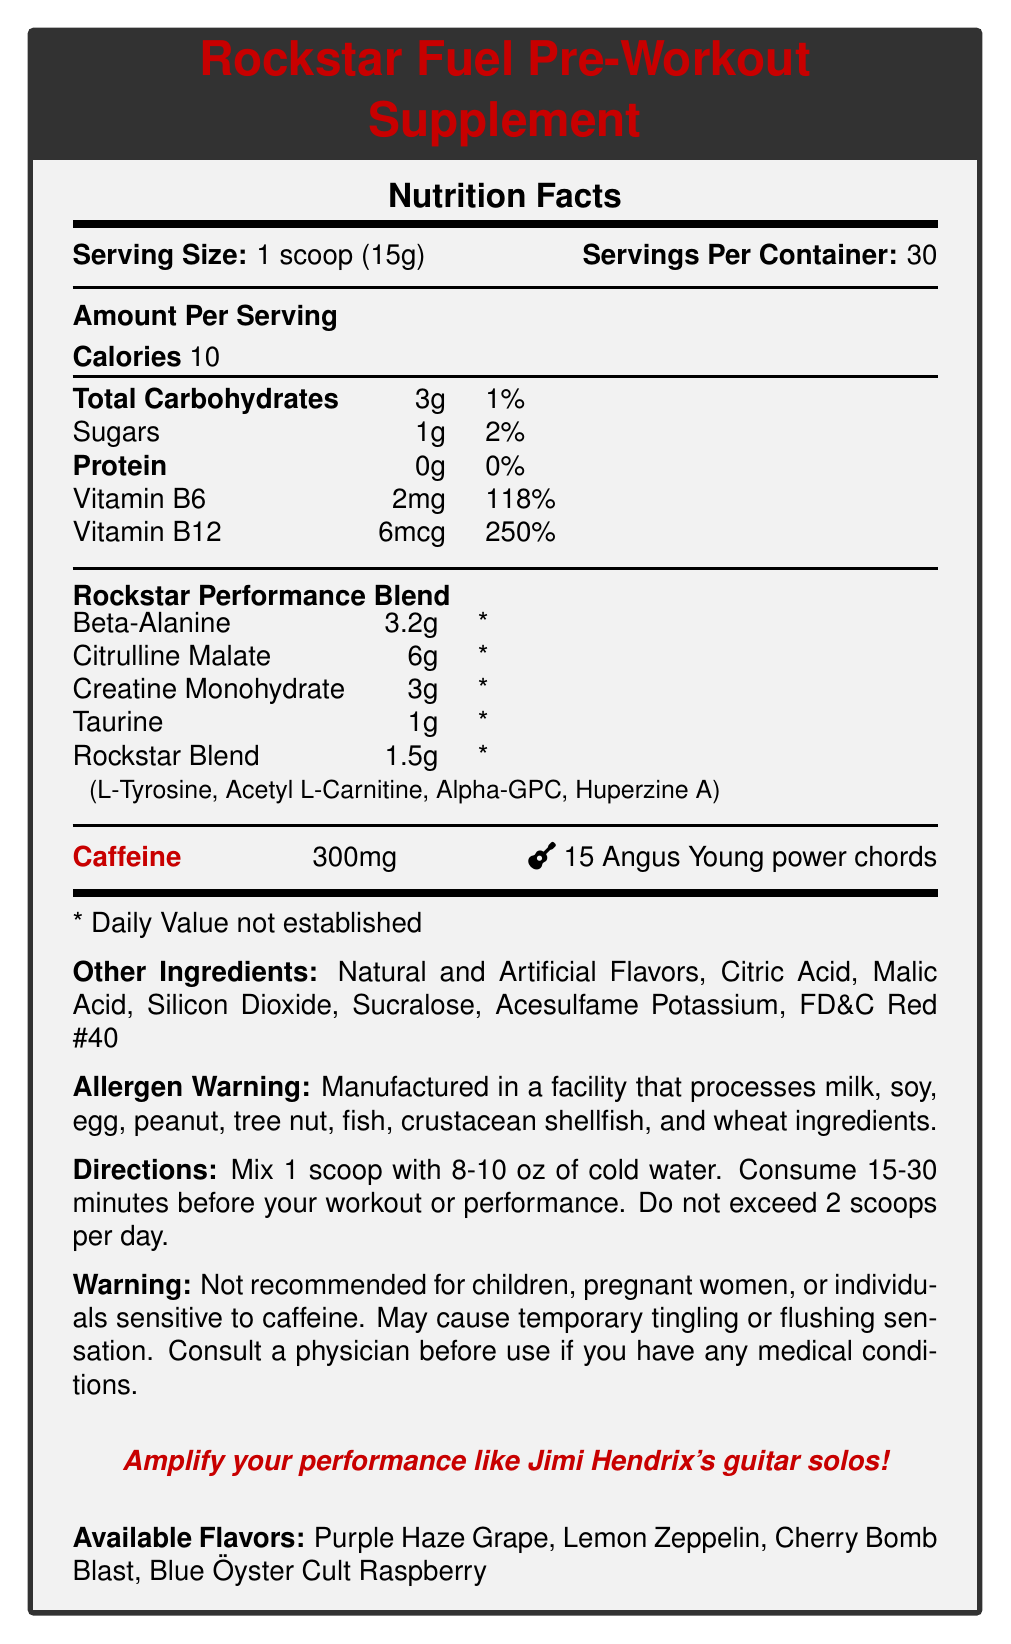what is the serving size for the Rockstar Fuel Pre-Workout Supplement? The document states the serving size directly as "1 scoop (15g)".
Answer: 1 scoop (15g) how many servings are in one container of Rockstar Fuel? The document indicates "Servings Per Container: 30".
Answer: 30 what is the caffeine content per serving measured in guitar riffs? The document specifies the caffeine content in an equivalent of "15 Angus Young power chords".
Answer: 15 Angus Young power chords what percentage of the daily value of Vitamin B12 is in each serving of Rockstar Fuel? It is listed in the document as "Vitamin B12 - 250%".
Answer: 250% name three ingredients in the Rockstar Blend. The ingredients are listed as "L-Tyrosine, Acetyl L-Carnitine, Alpha-GPC, Huperzine A".
Answer: L-Tyrosine, Acetyl L-Carnitine, Alpha-GPC what flavors are available for Rockstar Fuel? A. Purple Haze Grape B. Citrus Blitz C. Cherry Bomb Blast D. Blue Öyster Cult Raspberry The document lists "Purple Haze Grape", "Cherry Bomb Blast", and "Blue Öyster Cult Raspberry" as available flavors, but not "Citrus Blitz".
Answer: A, C, D which of the following ingredients is not included in the Rockstar Blend? I. L-Tyrosine II. Acetyl L-Carnitine III. Huperzine A IV. Caffeine The listed ingredients in the Rockstar Blend are "L-Tyrosine, Acetyl L-Carnitine, Alpha-GPC, Huperzine A", and caffeine is not included among them.
Answer: IV. Caffeine is there any protein in the Rockstar Fuel supplement? The document lists the protein content as "0g", which means there is no protein.
Answer: No is Rockstar Fuel recommended for children or pregnant women? The warning section clearly states that it is "Not recommended for children, pregnant women, or individuals sensitive to caffeine".
Answer: No summarize the main idea of the Rockstar Fuel Nutrition Facts Label. The label contains comprehensive nutritional details and instructions that guide the consumer about what the product includes and how to use it effectively.
Answer: The document is a Nutrition Facts Label for the Rockstar Fuel Pre-Workout Supplement, which includes detailed information on serving size, servings per container, caloric content, nutrient amounts and daily values, special blend ingredients, caffeine content, usage directions, warnings, marketing claims, and available flavors. how many calories are in each serving of Rockstar Fuel? The document states the caloric content as "Calories 10" per serving.
Answer: 10 what is the main marketing claim of Rockstar Fuel? The main marketing claim, highlighted in italics for emphasis, says, "Amplify your performance like Jimi Hendrix's guitar solos".
Answer: Amplify your performance like Jimi Hendrix's guitar solos can you determine the exact amount of daily value for beta-alanine from the document? The document lists the daily value for beta-alanine as "*", indicating it is not established.
Answer: Cannot be determined what specific warning is given about a physical sensation one might experience when consuming Rockstar Fuel? The warning section explicitly states that the supplement "May cause temporary tingling or flushing sensation".
Answer: May cause temporary tingling or flushing sensation is there any sugar in Rockstar Fuel and if so, how much? The document notes that there is "1g" of sugar per serving.
Answer: Yes, 1g 